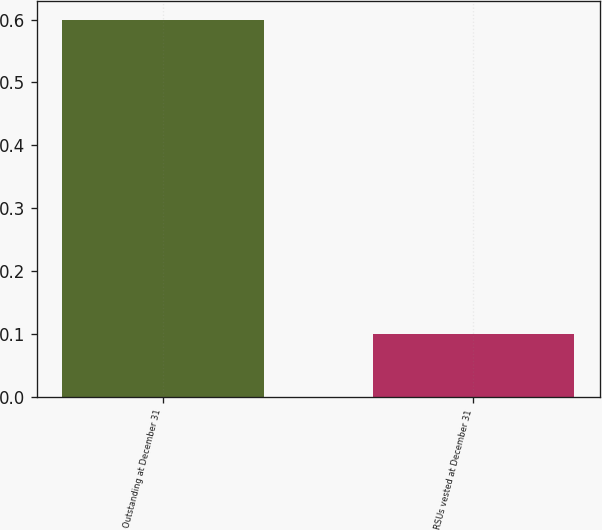<chart> <loc_0><loc_0><loc_500><loc_500><bar_chart><fcel>Outstanding at December 31<fcel>RSUs vested at December 31<nl><fcel>0.6<fcel>0.1<nl></chart> 